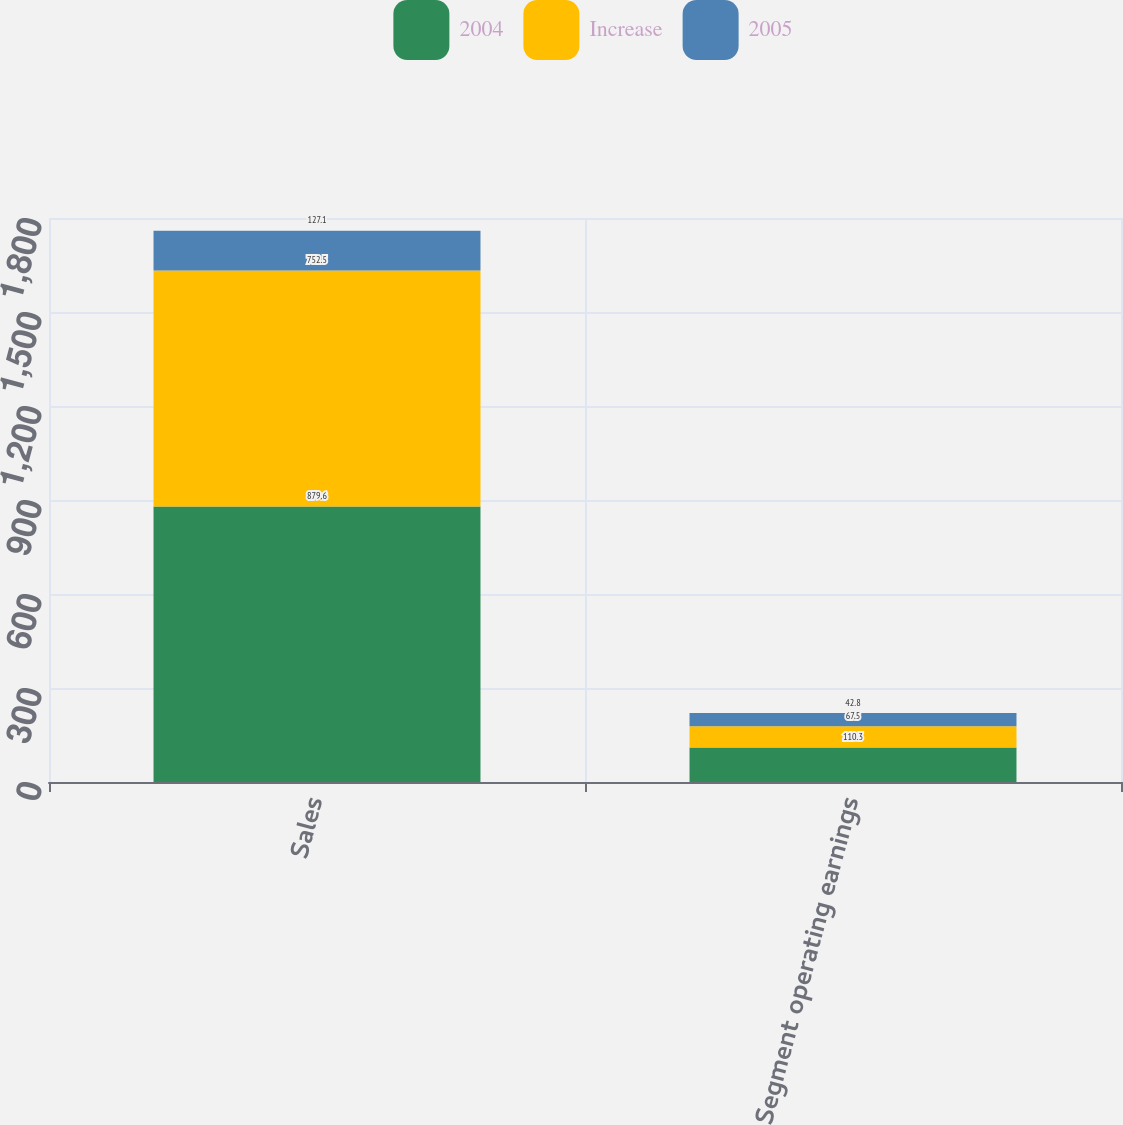<chart> <loc_0><loc_0><loc_500><loc_500><stacked_bar_chart><ecel><fcel>Sales<fcel>Segment operating earnings<nl><fcel>2004<fcel>879.6<fcel>110.3<nl><fcel>Increase<fcel>752.5<fcel>67.5<nl><fcel>2005<fcel>127.1<fcel>42.8<nl></chart> 